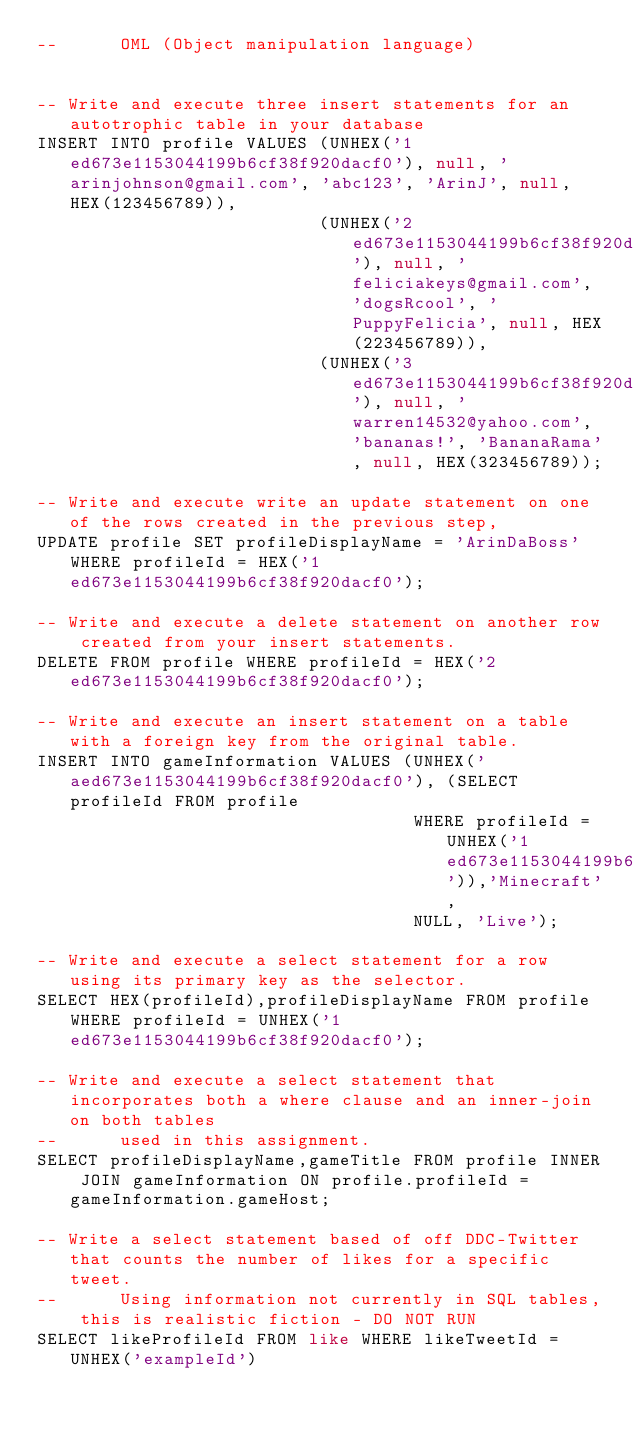Convert code to text. <code><loc_0><loc_0><loc_500><loc_500><_SQL_>--      OML (Object manipulation language)


-- Write and execute three insert statements for an autotrophic table in your database
INSERT INTO profile VALUES (UNHEX('1ed673e1153044199b6cf38f920dacf0'), null, 'arinjohnson@gmail.com', 'abc123', 'ArinJ', null, HEX(123456789)),
                           (UNHEX('2ed673e1153044199b6cf38f920dacf0'), null, 'feliciakeys@gmail.com', 'dogsRcool', 'PuppyFelicia', null, HEX(223456789)),
                           (UNHEX('3ed673e1153044199b6cf38f920dacf0'), null, 'warren14532@yahoo.com', 'bananas!', 'BananaRama', null, HEX(323456789));

-- Write and execute write an update statement on one of the rows created in the previous step,
UPDATE profile SET profileDisplayName = 'ArinDaBoss' WHERE profileId = HEX('1ed673e1153044199b6cf38f920dacf0');

-- Write and execute a delete statement on another row created from your insert statements.
DELETE FROM profile WHERE profileId = HEX('2ed673e1153044199b6cf38f920dacf0');

-- Write and execute an insert statement on a table with a foreign key from the original table.
INSERT INTO gameInformation VALUES (UNHEX('aed673e1153044199b6cf38f920dacf0'), (SELECT profileId FROM profile
                                    WHERE profileId = UNHEX('1ed673e1153044199b6cf38f920dacf0')),'Minecraft',
                                    NULL, 'Live');

-- Write and execute a select statement for a row using its primary key as the selector.
SELECT HEX(profileId),profileDisplayName FROM profile WHERE profileId = UNHEX('1ed673e1153044199b6cf38f920dacf0');

-- Write and execute a select statement that incorporates both a where clause and an inner-join on both tables
--      used in this assignment.
SELECT profileDisplayName,gameTitle FROM profile INNER JOIN gameInformation ON profile.profileId = gameInformation.gameHost;

-- Write a select statement based of off DDC-Twitter that counts the number of likes for a specific tweet.
--      Using information not currently in SQL tables, this is realistic fiction - DO NOT RUN
SELECT likeProfileId FROM like WHERE likeTweetId = UNHEX('exampleId')</code> 